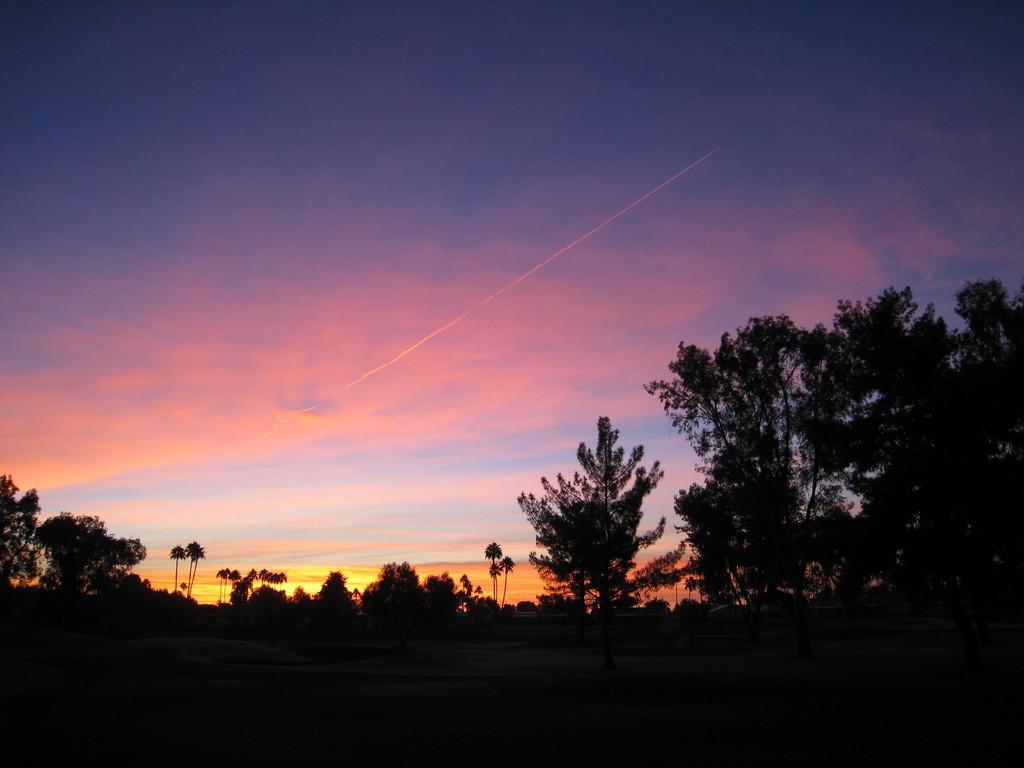In one or two sentences, can you explain what this image depicts? In this image, we can see so many trees, houses, ground. Background there is a sky. 